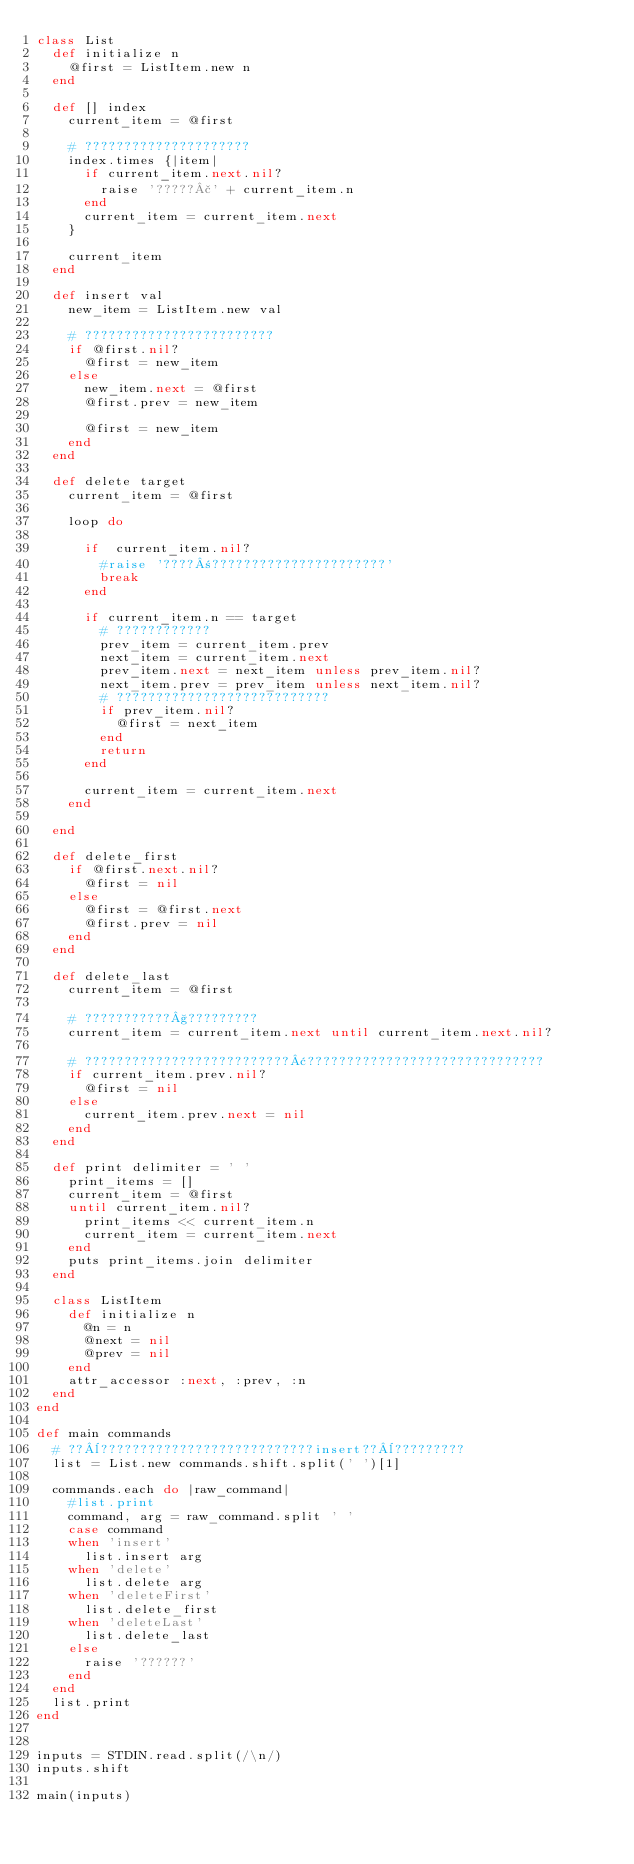Convert code to text. <code><loc_0><loc_0><loc_500><loc_500><_Ruby_>class List
  def initialize n
    @first = ListItem.new n
  end

  def [] index
    current_item = @first

    # ?????????????????????
    index.times {|item|
      if current_item.next.nil?
        raise '?????£' + current_item.n
      end
      current_item = current_item.next
    }

    current_item
  end

  def insert val
    new_item = ListItem.new val

    # ????????????????????????
    if @first.nil?
      @first = new_item
    else
      new_item.next = @first
      @first.prev = new_item

      @first = new_item
    end
  end

  def delete target
    current_item = @first

    loop do

      if  current_item.nil?
        #raise '????±??????????????????????'
        break
      end

      if current_item.n == target
        # ????????????
        prev_item = current_item.prev
        next_item = current_item.next
        prev_item.next = next_item unless prev_item.nil?
        next_item.prev = prev_item unless next_item.nil?
        # ???????????????????????????
        if prev_item.nil?
          @first = next_item
        end
        return
      end

      current_item = current_item.next
    end

  end

  def delete_first
    if @first.next.nil?
      @first = nil
    else
      @first = @first.next
      @first.prev = nil
    end
  end

  def delete_last
    current_item = @first

    # ???????????§?????????
    current_item = current_item.next until current_item.next.nil?

    # ??????????????????????????¢??????????????????????????????
    if current_item.prev.nil?
      @first = nil
    else
      current_item.prev.next = nil
    end
  end

  def print delimiter = ' '
    print_items = []
    current_item = @first
    until current_item.nil?
      print_items << current_item.n
      current_item = current_item.next
    end
    puts print_items.join delimiter
  end

  class ListItem
    def initialize n
      @n = n
      @next = nil
      @prev = nil
    end
    attr_accessor :next, :prev, :n
  end
end

def main commands
  # ??¨???????????????????????????insert??¨?????????
  list = List.new commands.shift.split(' ')[1]

  commands.each do |raw_command|
    #list.print
    command, arg = raw_command.split ' '
    case command
    when 'insert'
      list.insert arg
    when 'delete'
      list.delete arg
    when 'deleteFirst'
      list.delete_first
    when 'deleteLast'
      list.delete_last
    else
      raise '??????'
    end
  end
  list.print
end


inputs = STDIN.read.split(/\n/)
inputs.shift

main(inputs)</code> 